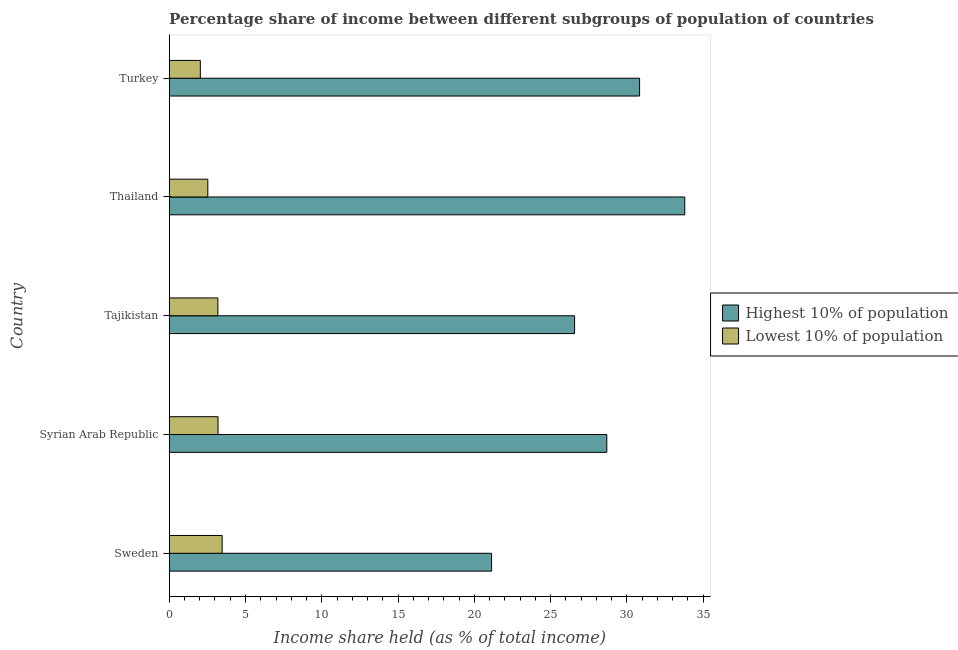How many different coloured bars are there?
Give a very brief answer. 2. How many groups of bars are there?
Your response must be concise. 5. Are the number of bars on each tick of the Y-axis equal?
Your answer should be compact. Yes. What is the label of the 4th group of bars from the top?
Provide a short and direct response. Syrian Arab Republic. In how many cases, is the number of bars for a given country not equal to the number of legend labels?
Keep it short and to the point. 0. What is the income share held by lowest 10% of the population in Tajikistan?
Keep it short and to the point. 3.19. Across all countries, what is the maximum income share held by lowest 10% of the population?
Provide a short and direct response. 3.47. Across all countries, what is the minimum income share held by lowest 10% of the population?
Keep it short and to the point. 2.04. In which country was the income share held by highest 10% of the population maximum?
Offer a very short reply. Thailand. What is the total income share held by highest 10% of the population in the graph?
Offer a terse response. 141. What is the difference between the income share held by highest 10% of the population in Syrian Arab Republic and that in Turkey?
Provide a succinct answer. -2.15. What is the difference between the income share held by lowest 10% of the population in Syrian Arab Republic and the income share held by highest 10% of the population in Tajikistan?
Keep it short and to the point. -23.37. What is the average income share held by lowest 10% of the population per country?
Provide a short and direct response. 2.89. What is the difference between the income share held by lowest 10% of the population and income share held by highest 10% of the population in Sweden?
Offer a very short reply. -17.66. What is the ratio of the income share held by highest 10% of the population in Sweden to that in Syrian Arab Republic?
Keep it short and to the point. 0.74. Is the income share held by highest 10% of the population in Sweden less than that in Syrian Arab Republic?
Your answer should be compact. Yes. What is the difference between the highest and the second highest income share held by highest 10% of the population?
Provide a short and direct response. 2.96. What is the difference between the highest and the lowest income share held by highest 10% of the population?
Keep it short and to the point. 12.66. In how many countries, is the income share held by highest 10% of the population greater than the average income share held by highest 10% of the population taken over all countries?
Provide a short and direct response. 3. What does the 1st bar from the top in Tajikistan represents?
Offer a terse response. Lowest 10% of population. What does the 2nd bar from the bottom in Sweden represents?
Keep it short and to the point. Lowest 10% of population. How many countries are there in the graph?
Make the answer very short. 5. What is the difference between two consecutive major ticks on the X-axis?
Your answer should be very brief. 5. Are the values on the major ticks of X-axis written in scientific E-notation?
Make the answer very short. No. Does the graph contain any zero values?
Provide a succinct answer. No. Does the graph contain grids?
Your response must be concise. No. How are the legend labels stacked?
Your answer should be very brief. Vertical. What is the title of the graph?
Give a very brief answer. Percentage share of income between different subgroups of population of countries. Does "National Visitors" appear as one of the legend labels in the graph?
Your answer should be compact. No. What is the label or title of the X-axis?
Ensure brevity in your answer.  Income share held (as % of total income). What is the Income share held (as % of total income) in Highest 10% of population in Sweden?
Provide a short and direct response. 21.13. What is the Income share held (as % of total income) in Lowest 10% of population in Sweden?
Offer a terse response. 3.47. What is the Income share held (as % of total income) of Highest 10% of population in Syrian Arab Republic?
Your answer should be very brief. 28.68. What is the Income share held (as % of total income) of Lowest 10% of population in Syrian Arab Republic?
Provide a succinct answer. 3.2. What is the Income share held (as % of total income) in Highest 10% of population in Tajikistan?
Your response must be concise. 26.57. What is the Income share held (as % of total income) in Lowest 10% of population in Tajikistan?
Your response must be concise. 3.19. What is the Income share held (as % of total income) in Highest 10% of population in Thailand?
Provide a succinct answer. 33.79. What is the Income share held (as % of total income) in Lowest 10% of population in Thailand?
Provide a short and direct response. 2.53. What is the Income share held (as % of total income) in Highest 10% of population in Turkey?
Offer a terse response. 30.83. What is the Income share held (as % of total income) of Lowest 10% of population in Turkey?
Make the answer very short. 2.04. Across all countries, what is the maximum Income share held (as % of total income) in Highest 10% of population?
Ensure brevity in your answer.  33.79. Across all countries, what is the maximum Income share held (as % of total income) in Lowest 10% of population?
Your answer should be compact. 3.47. Across all countries, what is the minimum Income share held (as % of total income) in Highest 10% of population?
Give a very brief answer. 21.13. Across all countries, what is the minimum Income share held (as % of total income) of Lowest 10% of population?
Give a very brief answer. 2.04. What is the total Income share held (as % of total income) in Highest 10% of population in the graph?
Make the answer very short. 141. What is the total Income share held (as % of total income) of Lowest 10% of population in the graph?
Keep it short and to the point. 14.43. What is the difference between the Income share held (as % of total income) of Highest 10% of population in Sweden and that in Syrian Arab Republic?
Your answer should be compact. -7.55. What is the difference between the Income share held (as % of total income) in Lowest 10% of population in Sweden and that in Syrian Arab Republic?
Offer a very short reply. 0.27. What is the difference between the Income share held (as % of total income) in Highest 10% of population in Sweden and that in Tajikistan?
Offer a very short reply. -5.44. What is the difference between the Income share held (as % of total income) of Lowest 10% of population in Sweden and that in Tajikistan?
Your answer should be very brief. 0.28. What is the difference between the Income share held (as % of total income) in Highest 10% of population in Sweden and that in Thailand?
Your answer should be compact. -12.66. What is the difference between the Income share held (as % of total income) in Lowest 10% of population in Sweden and that in Thailand?
Offer a very short reply. 0.94. What is the difference between the Income share held (as % of total income) in Highest 10% of population in Sweden and that in Turkey?
Give a very brief answer. -9.7. What is the difference between the Income share held (as % of total income) in Lowest 10% of population in Sweden and that in Turkey?
Provide a short and direct response. 1.43. What is the difference between the Income share held (as % of total income) of Highest 10% of population in Syrian Arab Republic and that in Tajikistan?
Offer a very short reply. 2.11. What is the difference between the Income share held (as % of total income) of Lowest 10% of population in Syrian Arab Republic and that in Tajikistan?
Provide a succinct answer. 0.01. What is the difference between the Income share held (as % of total income) in Highest 10% of population in Syrian Arab Republic and that in Thailand?
Ensure brevity in your answer.  -5.11. What is the difference between the Income share held (as % of total income) of Lowest 10% of population in Syrian Arab Republic and that in Thailand?
Your answer should be very brief. 0.67. What is the difference between the Income share held (as % of total income) in Highest 10% of population in Syrian Arab Republic and that in Turkey?
Make the answer very short. -2.15. What is the difference between the Income share held (as % of total income) in Lowest 10% of population in Syrian Arab Republic and that in Turkey?
Ensure brevity in your answer.  1.16. What is the difference between the Income share held (as % of total income) of Highest 10% of population in Tajikistan and that in Thailand?
Make the answer very short. -7.22. What is the difference between the Income share held (as % of total income) of Lowest 10% of population in Tajikistan and that in Thailand?
Offer a terse response. 0.66. What is the difference between the Income share held (as % of total income) of Highest 10% of population in Tajikistan and that in Turkey?
Make the answer very short. -4.26. What is the difference between the Income share held (as % of total income) in Lowest 10% of population in Tajikistan and that in Turkey?
Provide a succinct answer. 1.15. What is the difference between the Income share held (as % of total income) in Highest 10% of population in Thailand and that in Turkey?
Provide a succinct answer. 2.96. What is the difference between the Income share held (as % of total income) in Lowest 10% of population in Thailand and that in Turkey?
Provide a short and direct response. 0.49. What is the difference between the Income share held (as % of total income) in Highest 10% of population in Sweden and the Income share held (as % of total income) in Lowest 10% of population in Syrian Arab Republic?
Provide a short and direct response. 17.93. What is the difference between the Income share held (as % of total income) in Highest 10% of population in Sweden and the Income share held (as % of total income) in Lowest 10% of population in Tajikistan?
Your answer should be very brief. 17.94. What is the difference between the Income share held (as % of total income) of Highest 10% of population in Sweden and the Income share held (as % of total income) of Lowest 10% of population in Thailand?
Provide a succinct answer. 18.6. What is the difference between the Income share held (as % of total income) of Highest 10% of population in Sweden and the Income share held (as % of total income) of Lowest 10% of population in Turkey?
Offer a very short reply. 19.09. What is the difference between the Income share held (as % of total income) of Highest 10% of population in Syrian Arab Republic and the Income share held (as % of total income) of Lowest 10% of population in Tajikistan?
Your answer should be very brief. 25.49. What is the difference between the Income share held (as % of total income) of Highest 10% of population in Syrian Arab Republic and the Income share held (as % of total income) of Lowest 10% of population in Thailand?
Your answer should be compact. 26.15. What is the difference between the Income share held (as % of total income) of Highest 10% of population in Syrian Arab Republic and the Income share held (as % of total income) of Lowest 10% of population in Turkey?
Your response must be concise. 26.64. What is the difference between the Income share held (as % of total income) of Highest 10% of population in Tajikistan and the Income share held (as % of total income) of Lowest 10% of population in Thailand?
Keep it short and to the point. 24.04. What is the difference between the Income share held (as % of total income) of Highest 10% of population in Tajikistan and the Income share held (as % of total income) of Lowest 10% of population in Turkey?
Make the answer very short. 24.53. What is the difference between the Income share held (as % of total income) of Highest 10% of population in Thailand and the Income share held (as % of total income) of Lowest 10% of population in Turkey?
Offer a very short reply. 31.75. What is the average Income share held (as % of total income) of Highest 10% of population per country?
Provide a short and direct response. 28.2. What is the average Income share held (as % of total income) in Lowest 10% of population per country?
Provide a short and direct response. 2.89. What is the difference between the Income share held (as % of total income) of Highest 10% of population and Income share held (as % of total income) of Lowest 10% of population in Sweden?
Provide a short and direct response. 17.66. What is the difference between the Income share held (as % of total income) in Highest 10% of population and Income share held (as % of total income) in Lowest 10% of population in Syrian Arab Republic?
Offer a terse response. 25.48. What is the difference between the Income share held (as % of total income) in Highest 10% of population and Income share held (as % of total income) in Lowest 10% of population in Tajikistan?
Provide a short and direct response. 23.38. What is the difference between the Income share held (as % of total income) in Highest 10% of population and Income share held (as % of total income) in Lowest 10% of population in Thailand?
Give a very brief answer. 31.26. What is the difference between the Income share held (as % of total income) of Highest 10% of population and Income share held (as % of total income) of Lowest 10% of population in Turkey?
Ensure brevity in your answer.  28.79. What is the ratio of the Income share held (as % of total income) in Highest 10% of population in Sweden to that in Syrian Arab Republic?
Keep it short and to the point. 0.74. What is the ratio of the Income share held (as % of total income) of Lowest 10% of population in Sweden to that in Syrian Arab Republic?
Your response must be concise. 1.08. What is the ratio of the Income share held (as % of total income) of Highest 10% of population in Sweden to that in Tajikistan?
Keep it short and to the point. 0.8. What is the ratio of the Income share held (as % of total income) of Lowest 10% of population in Sweden to that in Tajikistan?
Keep it short and to the point. 1.09. What is the ratio of the Income share held (as % of total income) of Highest 10% of population in Sweden to that in Thailand?
Provide a short and direct response. 0.63. What is the ratio of the Income share held (as % of total income) in Lowest 10% of population in Sweden to that in Thailand?
Give a very brief answer. 1.37. What is the ratio of the Income share held (as % of total income) in Highest 10% of population in Sweden to that in Turkey?
Keep it short and to the point. 0.69. What is the ratio of the Income share held (as % of total income) of Lowest 10% of population in Sweden to that in Turkey?
Your answer should be very brief. 1.7. What is the ratio of the Income share held (as % of total income) in Highest 10% of population in Syrian Arab Republic to that in Tajikistan?
Your answer should be very brief. 1.08. What is the ratio of the Income share held (as % of total income) of Highest 10% of population in Syrian Arab Republic to that in Thailand?
Make the answer very short. 0.85. What is the ratio of the Income share held (as % of total income) in Lowest 10% of population in Syrian Arab Republic to that in Thailand?
Provide a short and direct response. 1.26. What is the ratio of the Income share held (as % of total income) of Highest 10% of population in Syrian Arab Republic to that in Turkey?
Provide a succinct answer. 0.93. What is the ratio of the Income share held (as % of total income) in Lowest 10% of population in Syrian Arab Republic to that in Turkey?
Provide a short and direct response. 1.57. What is the ratio of the Income share held (as % of total income) in Highest 10% of population in Tajikistan to that in Thailand?
Your answer should be very brief. 0.79. What is the ratio of the Income share held (as % of total income) in Lowest 10% of population in Tajikistan to that in Thailand?
Your answer should be compact. 1.26. What is the ratio of the Income share held (as % of total income) in Highest 10% of population in Tajikistan to that in Turkey?
Your answer should be compact. 0.86. What is the ratio of the Income share held (as % of total income) in Lowest 10% of population in Tajikistan to that in Turkey?
Offer a very short reply. 1.56. What is the ratio of the Income share held (as % of total income) in Highest 10% of population in Thailand to that in Turkey?
Offer a very short reply. 1.1. What is the ratio of the Income share held (as % of total income) in Lowest 10% of population in Thailand to that in Turkey?
Provide a short and direct response. 1.24. What is the difference between the highest and the second highest Income share held (as % of total income) of Highest 10% of population?
Provide a succinct answer. 2.96. What is the difference between the highest and the second highest Income share held (as % of total income) in Lowest 10% of population?
Give a very brief answer. 0.27. What is the difference between the highest and the lowest Income share held (as % of total income) in Highest 10% of population?
Ensure brevity in your answer.  12.66. What is the difference between the highest and the lowest Income share held (as % of total income) in Lowest 10% of population?
Ensure brevity in your answer.  1.43. 